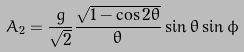Convert formula to latex. <formula><loc_0><loc_0><loc_500><loc_500>A _ { 2 } = \frac { g } { \sqrt { 2 } } \frac { \sqrt { 1 - \cos 2 \theta } } { \theta } \sin \theta \sin \phi</formula> 